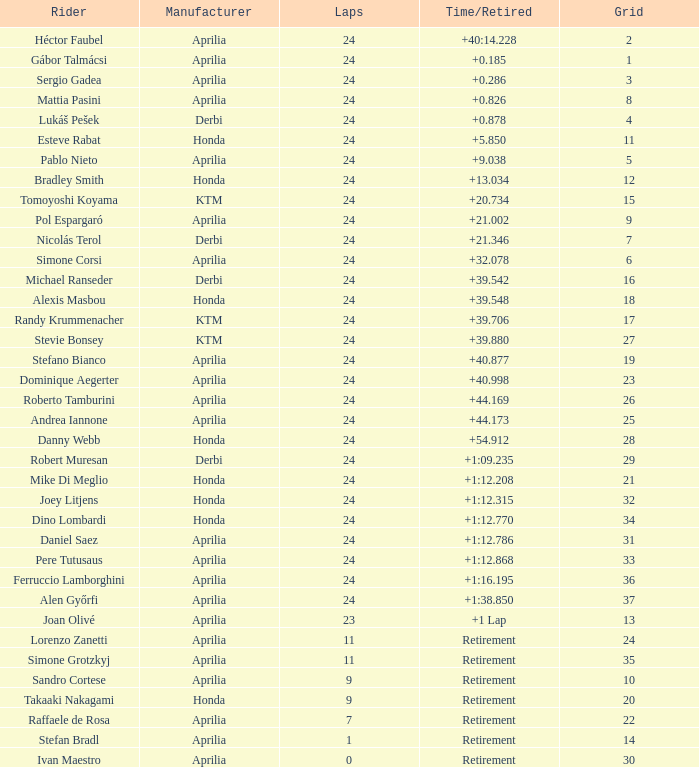How many grids correspond to more than 24 laps? None. 